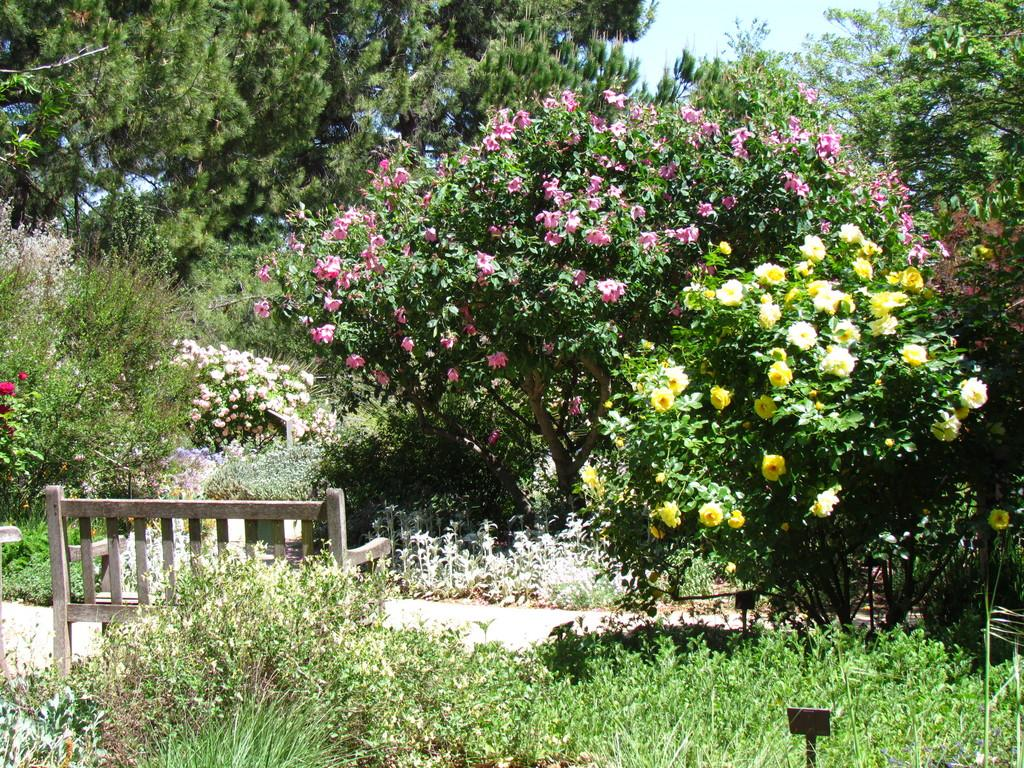What type of vegetation can be seen in the image? There are plants and trees in the image. Are there any specific features of the trees in the image? Yes, there are trees with flowers in the image. What type of seating is present in the image? There is a bench in the image. What can be seen in the background of the image? The sky is visible in the background of the image. What type of boundary can be seen in the image? There is no boundary present in the image. What type of sheet is covering the plants in the image? There is no sheet covering the plants in the image; they are exposed to the environment. 